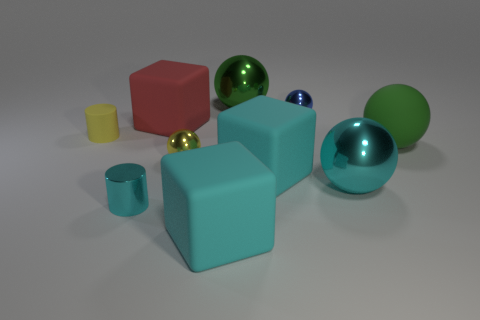How many objects have the same color as the rubber sphere?
Provide a succinct answer. 1. What is the material of the tiny cylinder in front of the big ball to the right of the large shiny object that is on the right side of the tiny blue sphere?
Offer a terse response. Metal. How many cyan things are large matte spheres or metallic cylinders?
Ensure brevity in your answer.  1. There is a rubber cube that is left of the cyan cube on the left side of the green object that is left of the large green rubber object; what is its size?
Your answer should be very brief. Large. There is a blue thing that is the same shape as the big cyan shiny thing; what is its size?
Your answer should be compact. Small. What number of small objects are cyan spheres or cyan metallic things?
Your answer should be very brief. 1. Do the yellow sphere behind the tiny cyan metal cylinder and the green thing on the left side of the blue shiny object have the same material?
Your response must be concise. Yes. What material is the green sphere that is left of the green rubber sphere?
Provide a succinct answer. Metal. What number of matte things are balls or big cyan objects?
Make the answer very short. 3. The large cube that is behind the yellow cylinder behind the tiny yellow metal object is what color?
Your answer should be very brief. Red. 